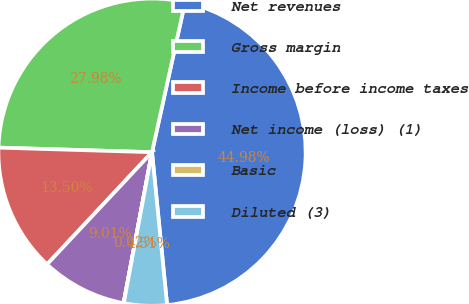Convert chart to OTSL. <chart><loc_0><loc_0><loc_500><loc_500><pie_chart><fcel>Net revenues<fcel>Gross margin<fcel>Income before income taxes<fcel>Net income (loss) (1)<fcel>Basic<fcel>Diluted (3)<nl><fcel>44.98%<fcel>27.98%<fcel>13.5%<fcel>9.01%<fcel>0.02%<fcel>4.51%<nl></chart> 